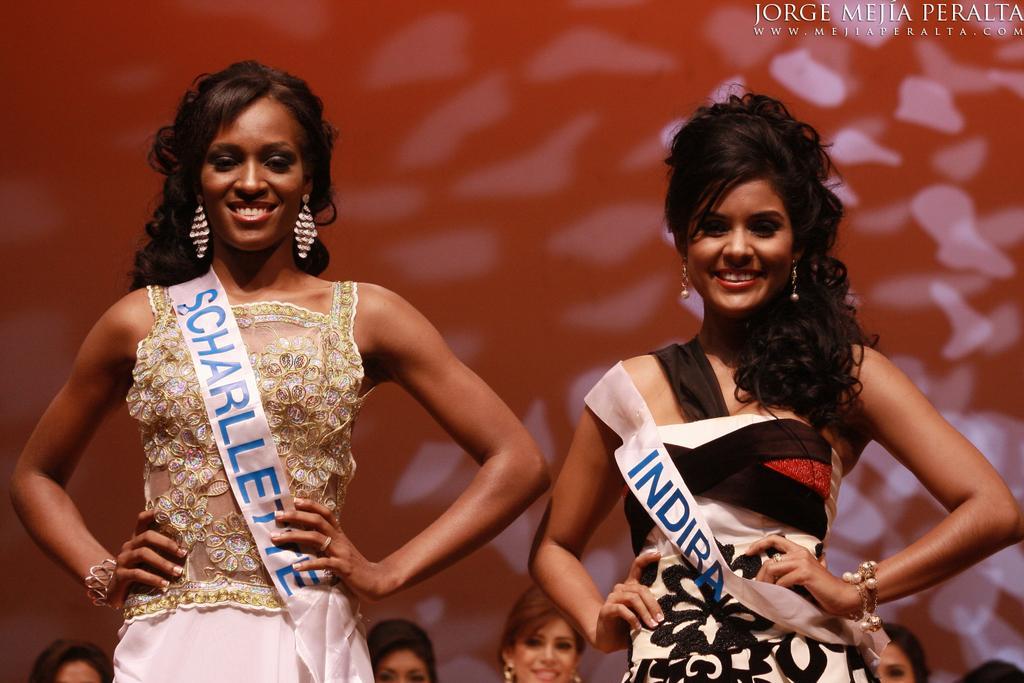Please provide a concise description of this image. In this image there are two women giving pose for a photograph, in the background there are people standing and there is a wall, on the top right there is some text. 